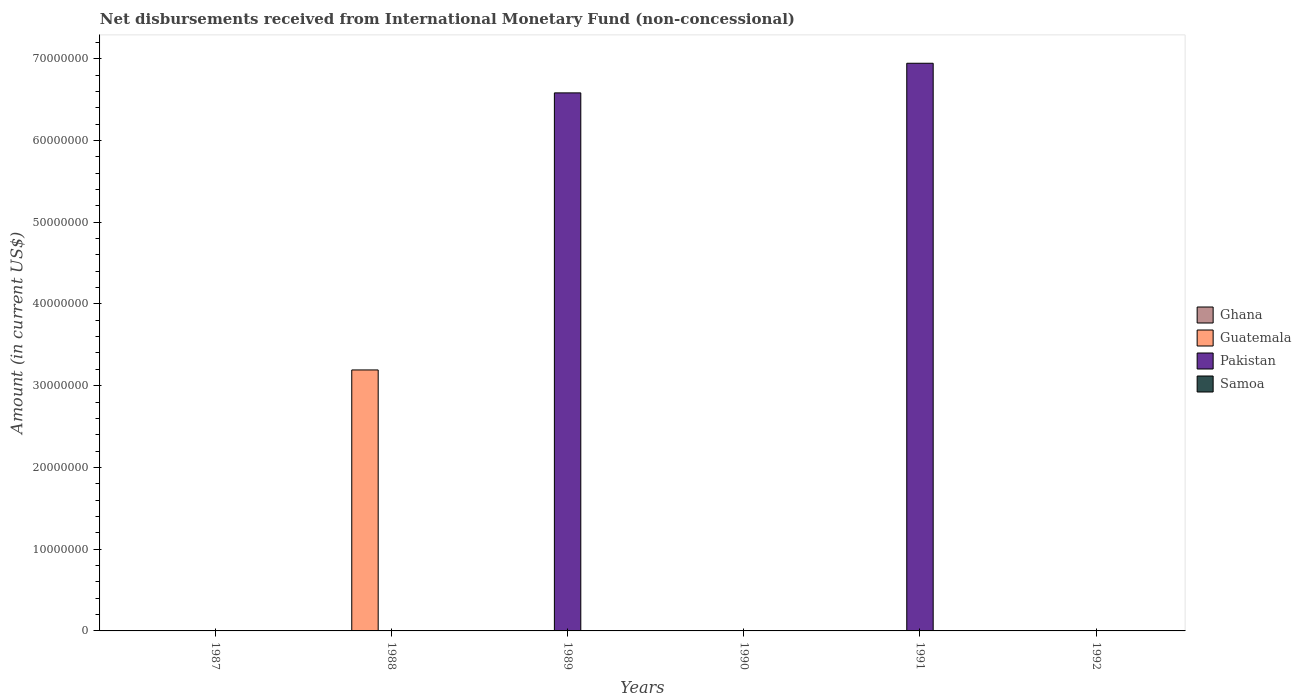Are the number of bars per tick equal to the number of legend labels?
Offer a very short reply. No. How many bars are there on the 3rd tick from the left?
Your response must be concise. 1. How many bars are there on the 4th tick from the right?
Make the answer very short. 1. What is the amount of disbursements received from International Monetary Fund in Pakistan in 1989?
Your response must be concise. 6.58e+07. Across all years, what is the maximum amount of disbursements received from International Monetary Fund in Pakistan?
Provide a short and direct response. 6.94e+07. What is the total amount of disbursements received from International Monetary Fund in Ghana in the graph?
Your answer should be compact. 0. In how many years, is the amount of disbursements received from International Monetary Fund in Guatemala greater than 24000000 US$?
Give a very brief answer. 1. What is the difference between the highest and the lowest amount of disbursements received from International Monetary Fund in Guatemala?
Offer a very short reply. 3.19e+07. Is it the case that in every year, the sum of the amount of disbursements received from International Monetary Fund in Samoa and amount of disbursements received from International Monetary Fund in Ghana is greater than the amount of disbursements received from International Monetary Fund in Pakistan?
Offer a very short reply. No. How many bars are there?
Your answer should be very brief. 3. Are all the bars in the graph horizontal?
Offer a very short reply. No. How many years are there in the graph?
Offer a very short reply. 6. What is the difference between two consecutive major ticks on the Y-axis?
Provide a succinct answer. 1.00e+07. Are the values on the major ticks of Y-axis written in scientific E-notation?
Provide a short and direct response. No. Does the graph contain any zero values?
Ensure brevity in your answer.  Yes. Where does the legend appear in the graph?
Keep it short and to the point. Center right. How many legend labels are there?
Provide a short and direct response. 4. How are the legend labels stacked?
Your response must be concise. Vertical. What is the title of the graph?
Your response must be concise. Net disbursements received from International Monetary Fund (non-concessional). Does "Euro area" appear as one of the legend labels in the graph?
Offer a very short reply. No. What is the label or title of the Y-axis?
Your answer should be compact. Amount (in current US$). What is the Amount (in current US$) in Guatemala in 1987?
Offer a very short reply. 0. What is the Amount (in current US$) in Samoa in 1987?
Your answer should be very brief. 0. What is the Amount (in current US$) of Guatemala in 1988?
Offer a very short reply. 3.19e+07. What is the Amount (in current US$) in Pakistan in 1988?
Offer a terse response. 0. What is the Amount (in current US$) in Ghana in 1989?
Give a very brief answer. 0. What is the Amount (in current US$) in Guatemala in 1989?
Provide a short and direct response. 0. What is the Amount (in current US$) of Pakistan in 1989?
Provide a succinct answer. 6.58e+07. What is the Amount (in current US$) of Guatemala in 1990?
Make the answer very short. 0. What is the Amount (in current US$) in Pakistan in 1990?
Provide a short and direct response. 0. What is the Amount (in current US$) of Ghana in 1991?
Make the answer very short. 0. What is the Amount (in current US$) in Pakistan in 1991?
Your answer should be compact. 6.94e+07. What is the Amount (in current US$) in Samoa in 1992?
Your response must be concise. 0. Across all years, what is the maximum Amount (in current US$) in Guatemala?
Provide a short and direct response. 3.19e+07. Across all years, what is the maximum Amount (in current US$) in Pakistan?
Provide a succinct answer. 6.94e+07. Across all years, what is the minimum Amount (in current US$) of Pakistan?
Offer a very short reply. 0. What is the total Amount (in current US$) in Ghana in the graph?
Provide a succinct answer. 0. What is the total Amount (in current US$) of Guatemala in the graph?
Your response must be concise. 3.19e+07. What is the total Amount (in current US$) in Pakistan in the graph?
Provide a short and direct response. 1.35e+08. What is the difference between the Amount (in current US$) of Pakistan in 1989 and that in 1991?
Provide a short and direct response. -3.62e+06. What is the difference between the Amount (in current US$) in Guatemala in 1988 and the Amount (in current US$) in Pakistan in 1989?
Provide a short and direct response. -3.39e+07. What is the difference between the Amount (in current US$) in Guatemala in 1988 and the Amount (in current US$) in Pakistan in 1991?
Your response must be concise. -3.75e+07. What is the average Amount (in current US$) in Ghana per year?
Provide a succinct answer. 0. What is the average Amount (in current US$) in Guatemala per year?
Offer a terse response. 5.32e+06. What is the average Amount (in current US$) in Pakistan per year?
Your answer should be very brief. 2.25e+07. What is the ratio of the Amount (in current US$) of Pakistan in 1989 to that in 1991?
Your answer should be very brief. 0.95. What is the difference between the highest and the lowest Amount (in current US$) of Guatemala?
Provide a succinct answer. 3.19e+07. What is the difference between the highest and the lowest Amount (in current US$) in Pakistan?
Provide a short and direct response. 6.94e+07. 